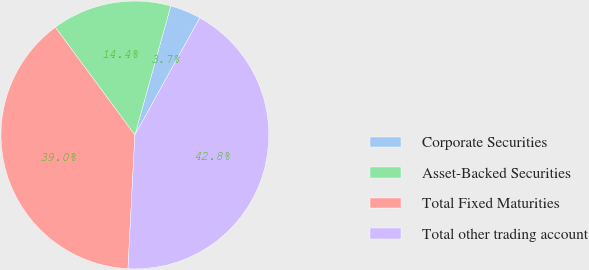Convert chart. <chart><loc_0><loc_0><loc_500><loc_500><pie_chart><fcel>Corporate Securities<fcel>Asset-Backed Securities<fcel>Total Fixed Maturities<fcel>Total other trading account<nl><fcel>3.74%<fcel>14.44%<fcel>39.05%<fcel>42.77%<nl></chart> 